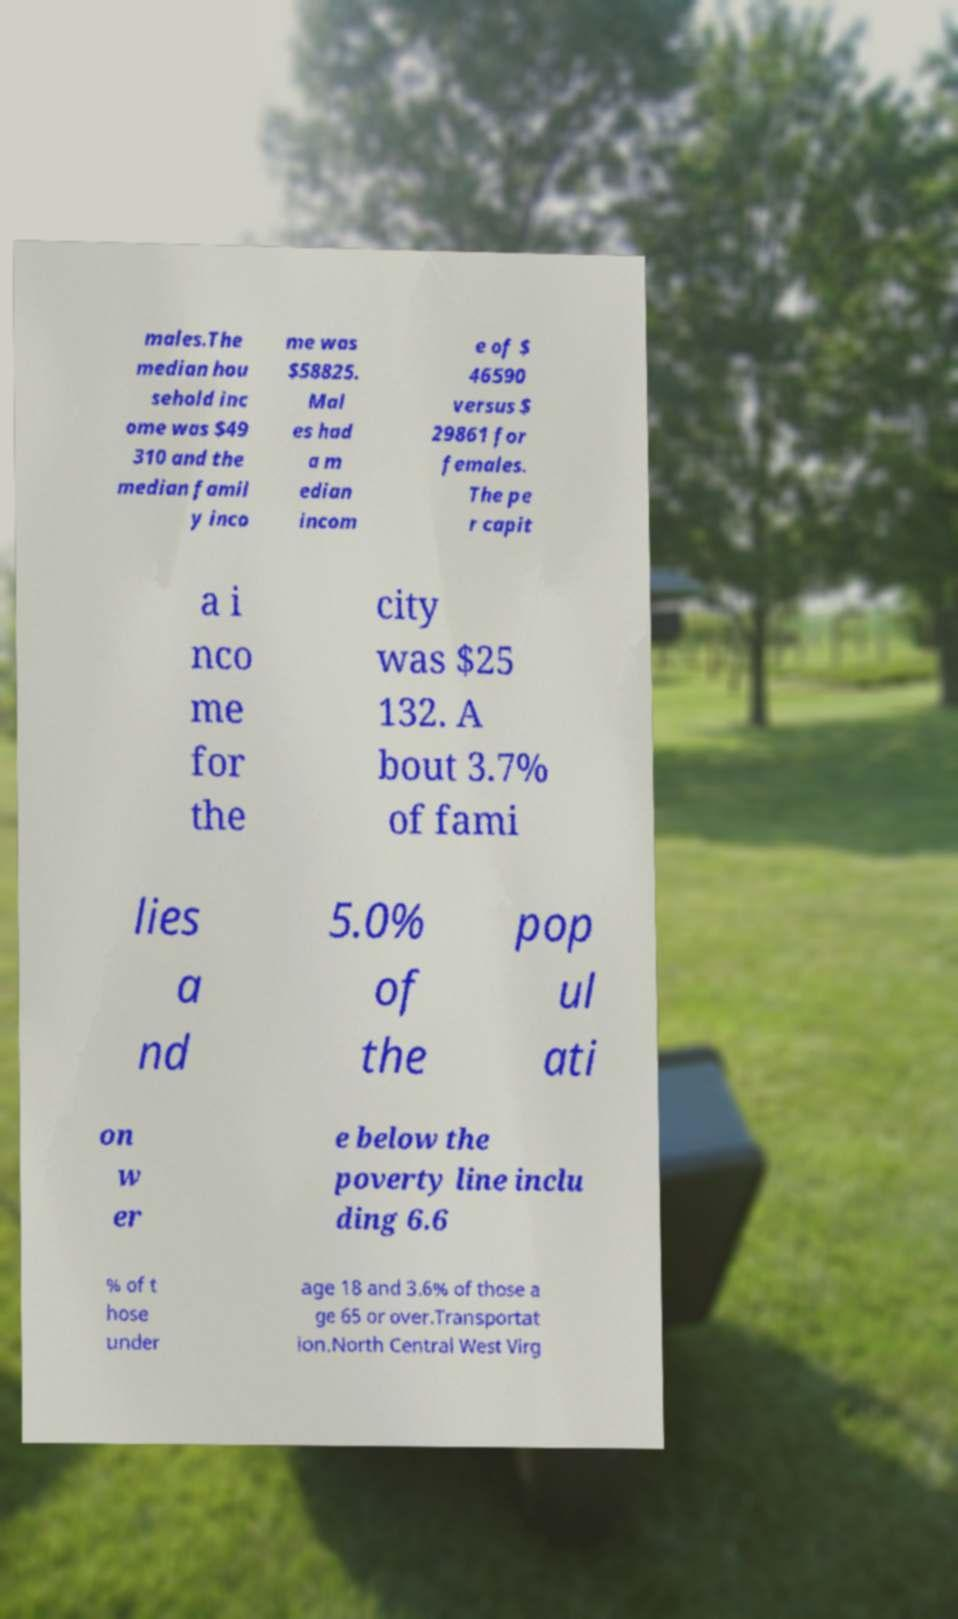There's text embedded in this image that I need extracted. Can you transcribe it verbatim? males.The median hou sehold inc ome was $49 310 and the median famil y inco me was $58825. Mal es had a m edian incom e of $ 46590 versus $ 29861 for females. The pe r capit a i nco me for the city was $25 132. A bout 3.7% of fami lies a nd 5.0% of the pop ul ati on w er e below the poverty line inclu ding 6.6 % of t hose under age 18 and 3.6% of those a ge 65 or over.Transportat ion.North Central West Virg 